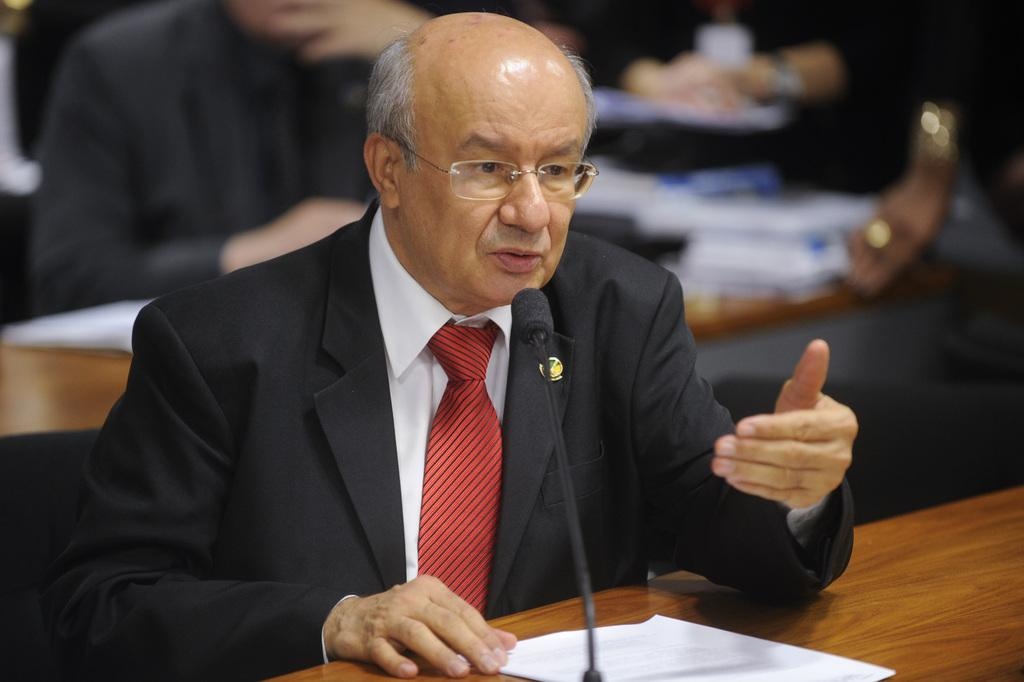What is the person in the image doing? The person is sitting in the image. What is the person wearing? The person is wearing a suit. What objects are on the table in the image? There is a microphone and a paper on a table in the image. How would you describe the background of the image? The background of the image is blurred. Can you see any squirrels attending the party in the image? There is no party or squirrels present in the image. 